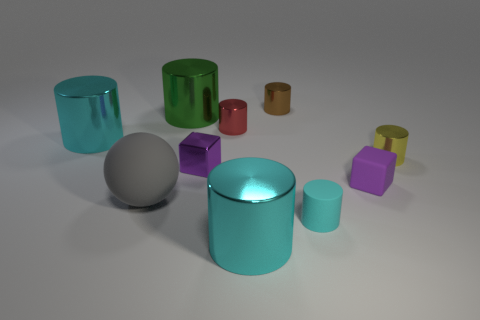Subtract all big green cylinders. How many cylinders are left? 6 Subtract all gray cubes. How many cyan cylinders are left? 3 Subtract all brown cylinders. How many cylinders are left? 6 Subtract all green cylinders. Subtract all cyan cubes. How many cylinders are left? 6 Subtract all spheres. How many objects are left? 9 Add 2 tiny red metal things. How many tiny red metal things exist? 3 Subtract 1 purple blocks. How many objects are left? 9 Subtract all big green cylinders. Subtract all tiny purple things. How many objects are left? 7 Add 5 large cylinders. How many large cylinders are left? 8 